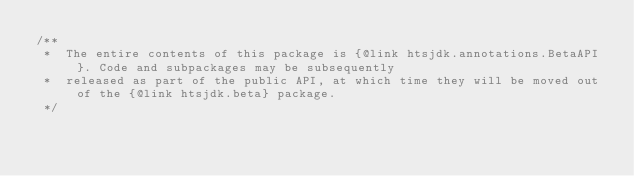<code> <loc_0><loc_0><loc_500><loc_500><_Java_>/**
 *  The entire contents of this package is {@link htsjdk.annotations.BetaAPI}. Code and subpackages may be subsequently
 *  released as part of the public API, at which time they will be moved out of the {@link htsjdk.beta} package.
 */
</code> 